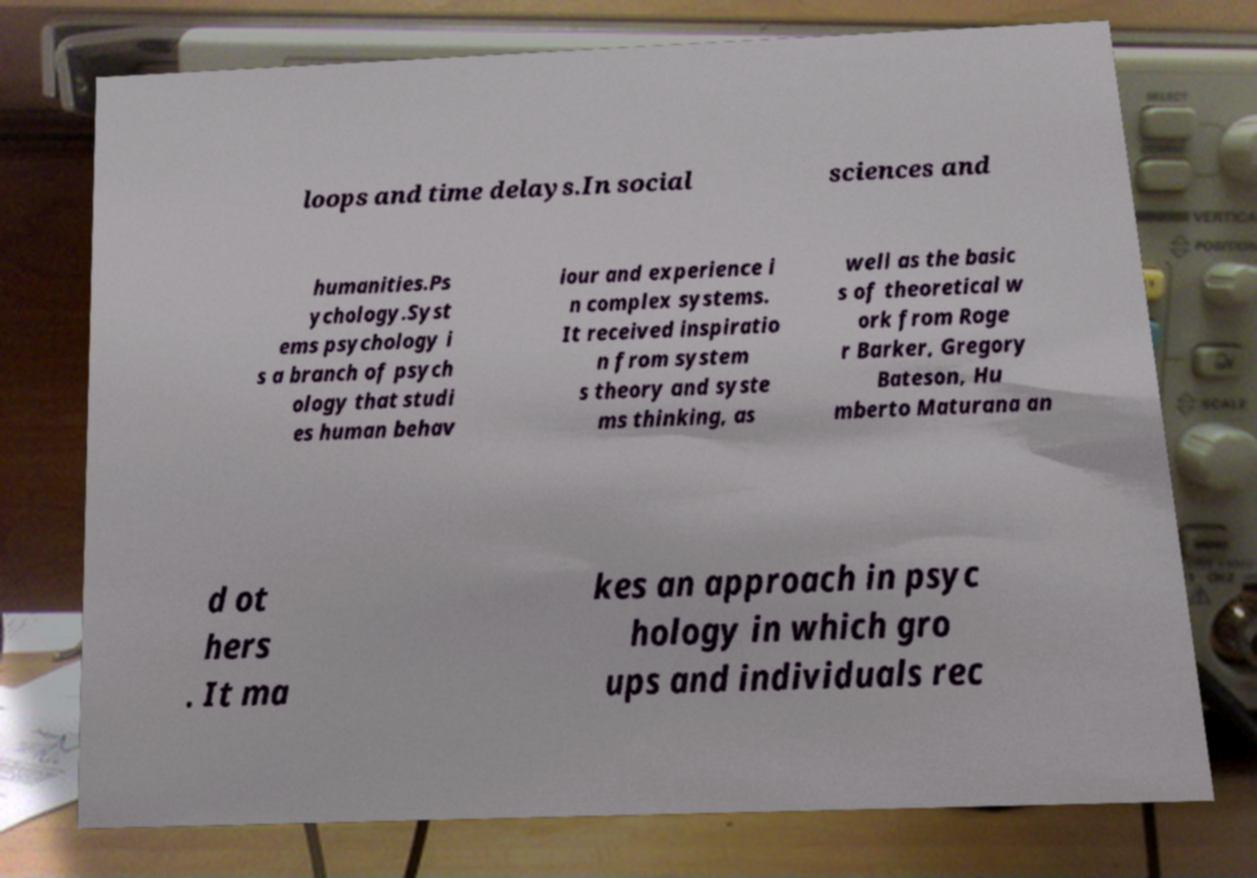Could you assist in decoding the text presented in this image and type it out clearly? loops and time delays.In social sciences and humanities.Ps ychology.Syst ems psychology i s a branch of psych ology that studi es human behav iour and experience i n complex systems. It received inspiratio n from system s theory and syste ms thinking, as well as the basic s of theoretical w ork from Roge r Barker, Gregory Bateson, Hu mberto Maturana an d ot hers . It ma kes an approach in psyc hology in which gro ups and individuals rec 